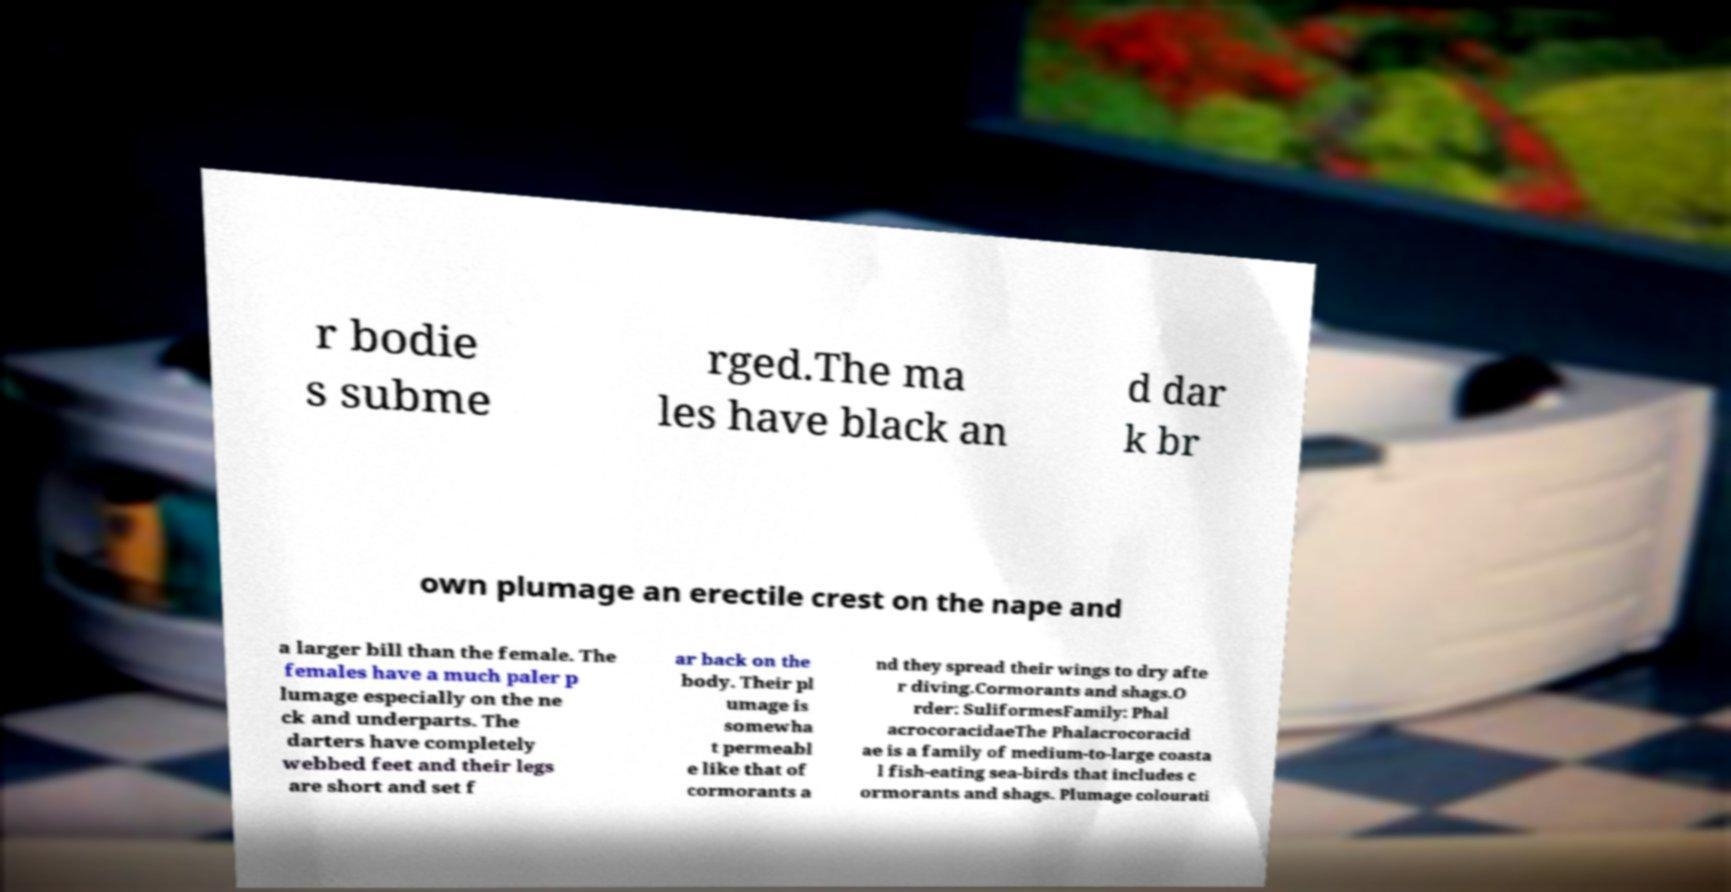Can you accurately transcribe the text from the provided image for me? r bodie s subme rged.The ma les have black an d dar k br own plumage an erectile crest on the nape and a larger bill than the female. The females have a much paler p lumage especially on the ne ck and underparts. The darters have completely webbed feet and their legs are short and set f ar back on the body. Their pl umage is somewha t permeabl e like that of cormorants a nd they spread their wings to dry afte r diving.Cormorants and shags.O rder: SuliformesFamily: Phal acrocoracidaeThe Phalacrocoracid ae is a family of medium-to-large coasta l fish-eating sea-birds that includes c ormorants and shags. Plumage colourati 